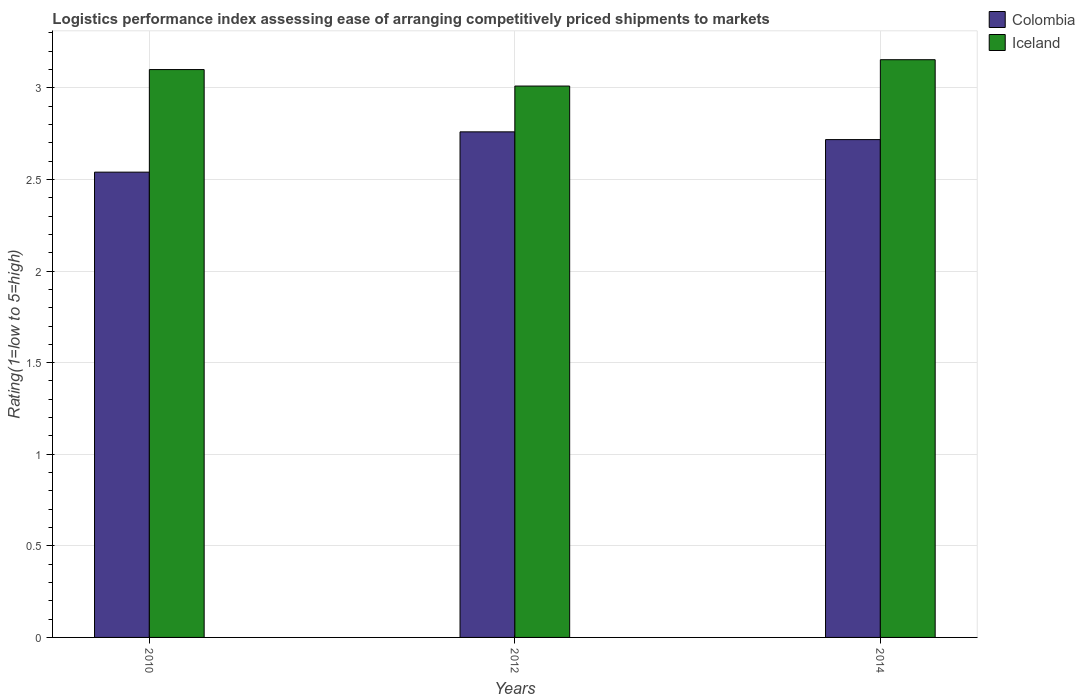How many groups of bars are there?
Offer a very short reply. 3. Are the number of bars per tick equal to the number of legend labels?
Offer a terse response. Yes. How many bars are there on the 3rd tick from the right?
Provide a short and direct response. 2. What is the label of the 2nd group of bars from the left?
Ensure brevity in your answer.  2012. What is the Logistic performance index in Iceland in 2014?
Your answer should be very brief. 3.15. Across all years, what is the maximum Logistic performance index in Iceland?
Give a very brief answer. 3.15. Across all years, what is the minimum Logistic performance index in Colombia?
Provide a succinct answer. 2.54. In which year was the Logistic performance index in Colombia maximum?
Your response must be concise. 2012. In which year was the Logistic performance index in Iceland minimum?
Offer a very short reply. 2012. What is the total Logistic performance index in Colombia in the graph?
Your response must be concise. 8.02. What is the difference between the Logistic performance index in Colombia in 2012 and that in 2014?
Your answer should be very brief. 0.04. What is the difference between the Logistic performance index in Colombia in 2014 and the Logistic performance index in Iceland in 2012?
Make the answer very short. -0.29. What is the average Logistic performance index in Colombia per year?
Offer a very short reply. 2.67. In the year 2012, what is the difference between the Logistic performance index in Colombia and Logistic performance index in Iceland?
Offer a terse response. -0.25. What is the ratio of the Logistic performance index in Iceland in 2010 to that in 2012?
Provide a short and direct response. 1.03. Is the Logistic performance index in Colombia in 2010 less than that in 2014?
Provide a succinct answer. Yes. What is the difference between the highest and the second highest Logistic performance index in Colombia?
Your answer should be compact. 0.04. What is the difference between the highest and the lowest Logistic performance index in Colombia?
Provide a short and direct response. 0.22. In how many years, is the Logistic performance index in Iceland greater than the average Logistic performance index in Iceland taken over all years?
Offer a terse response. 2. Is the sum of the Logistic performance index in Iceland in 2012 and 2014 greater than the maximum Logistic performance index in Colombia across all years?
Your answer should be very brief. Yes. What does the 1st bar from the left in 2010 represents?
Provide a short and direct response. Colombia. What does the 2nd bar from the right in 2014 represents?
Keep it short and to the point. Colombia. How many years are there in the graph?
Provide a short and direct response. 3. What is the difference between two consecutive major ticks on the Y-axis?
Offer a very short reply. 0.5. Are the values on the major ticks of Y-axis written in scientific E-notation?
Provide a succinct answer. No. Does the graph contain any zero values?
Provide a succinct answer. No. Where does the legend appear in the graph?
Make the answer very short. Top right. What is the title of the graph?
Ensure brevity in your answer.  Logistics performance index assessing ease of arranging competitively priced shipments to markets. Does "Latvia" appear as one of the legend labels in the graph?
Your answer should be compact. No. What is the label or title of the Y-axis?
Offer a terse response. Rating(1=low to 5=high). What is the Rating(1=low to 5=high) in Colombia in 2010?
Offer a very short reply. 2.54. What is the Rating(1=low to 5=high) in Iceland in 2010?
Your answer should be compact. 3.1. What is the Rating(1=low to 5=high) in Colombia in 2012?
Provide a short and direct response. 2.76. What is the Rating(1=low to 5=high) in Iceland in 2012?
Keep it short and to the point. 3.01. What is the Rating(1=low to 5=high) of Colombia in 2014?
Your response must be concise. 2.72. What is the Rating(1=low to 5=high) of Iceland in 2014?
Give a very brief answer. 3.15. Across all years, what is the maximum Rating(1=low to 5=high) of Colombia?
Keep it short and to the point. 2.76. Across all years, what is the maximum Rating(1=low to 5=high) of Iceland?
Your answer should be very brief. 3.15. Across all years, what is the minimum Rating(1=low to 5=high) of Colombia?
Provide a short and direct response. 2.54. Across all years, what is the minimum Rating(1=low to 5=high) of Iceland?
Ensure brevity in your answer.  3.01. What is the total Rating(1=low to 5=high) of Colombia in the graph?
Keep it short and to the point. 8.02. What is the total Rating(1=low to 5=high) of Iceland in the graph?
Keep it short and to the point. 9.26. What is the difference between the Rating(1=low to 5=high) of Colombia in 2010 and that in 2012?
Offer a very short reply. -0.22. What is the difference between the Rating(1=low to 5=high) in Iceland in 2010 and that in 2012?
Offer a terse response. 0.09. What is the difference between the Rating(1=low to 5=high) in Colombia in 2010 and that in 2014?
Your answer should be compact. -0.18. What is the difference between the Rating(1=low to 5=high) of Iceland in 2010 and that in 2014?
Provide a short and direct response. -0.05. What is the difference between the Rating(1=low to 5=high) in Colombia in 2012 and that in 2014?
Make the answer very short. 0.04. What is the difference between the Rating(1=low to 5=high) of Iceland in 2012 and that in 2014?
Keep it short and to the point. -0.14. What is the difference between the Rating(1=low to 5=high) in Colombia in 2010 and the Rating(1=low to 5=high) in Iceland in 2012?
Offer a terse response. -0.47. What is the difference between the Rating(1=low to 5=high) in Colombia in 2010 and the Rating(1=low to 5=high) in Iceland in 2014?
Keep it short and to the point. -0.61. What is the difference between the Rating(1=low to 5=high) in Colombia in 2012 and the Rating(1=low to 5=high) in Iceland in 2014?
Give a very brief answer. -0.39. What is the average Rating(1=low to 5=high) in Colombia per year?
Your response must be concise. 2.67. What is the average Rating(1=low to 5=high) of Iceland per year?
Offer a very short reply. 3.09. In the year 2010, what is the difference between the Rating(1=low to 5=high) in Colombia and Rating(1=low to 5=high) in Iceland?
Keep it short and to the point. -0.56. In the year 2012, what is the difference between the Rating(1=low to 5=high) of Colombia and Rating(1=low to 5=high) of Iceland?
Your answer should be very brief. -0.25. In the year 2014, what is the difference between the Rating(1=low to 5=high) of Colombia and Rating(1=low to 5=high) of Iceland?
Provide a succinct answer. -0.44. What is the ratio of the Rating(1=low to 5=high) of Colombia in 2010 to that in 2012?
Provide a short and direct response. 0.92. What is the ratio of the Rating(1=low to 5=high) in Iceland in 2010 to that in 2012?
Your answer should be compact. 1.03. What is the ratio of the Rating(1=low to 5=high) of Colombia in 2010 to that in 2014?
Keep it short and to the point. 0.93. What is the ratio of the Rating(1=low to 5=high) in Iceland in 2010 to that in 2014?
Provide a short and direct response. 0.98. What is the ratio of the Rating(1=low to 5=high) of Colombia in 2012 to that in 2014?
Provide a succinct answer. 1.02. What is the ratio of the Rating(1=low to 5=high) in Iceland in 2012 to that in 2014?
Give a very brief answer. 0.95. What is the difference between the highest and the second highest Rating(1=low to 5=high) of Colombia?
Your response must be concise. 0.04. What is the difference between the highest and the second highest Rating(1=low to 5=high) in Iceland?
Provide a short and direct response. 0.05. What is the difference between the highest and the lowest Rating(1=low to 5=high) in Colombia?
Provide a succinct answer. 0.22. What is the difference between the highest and the lowest Rating(1=low to 5=high) in Iceland?
Provide a succinct answer. 0.14. 